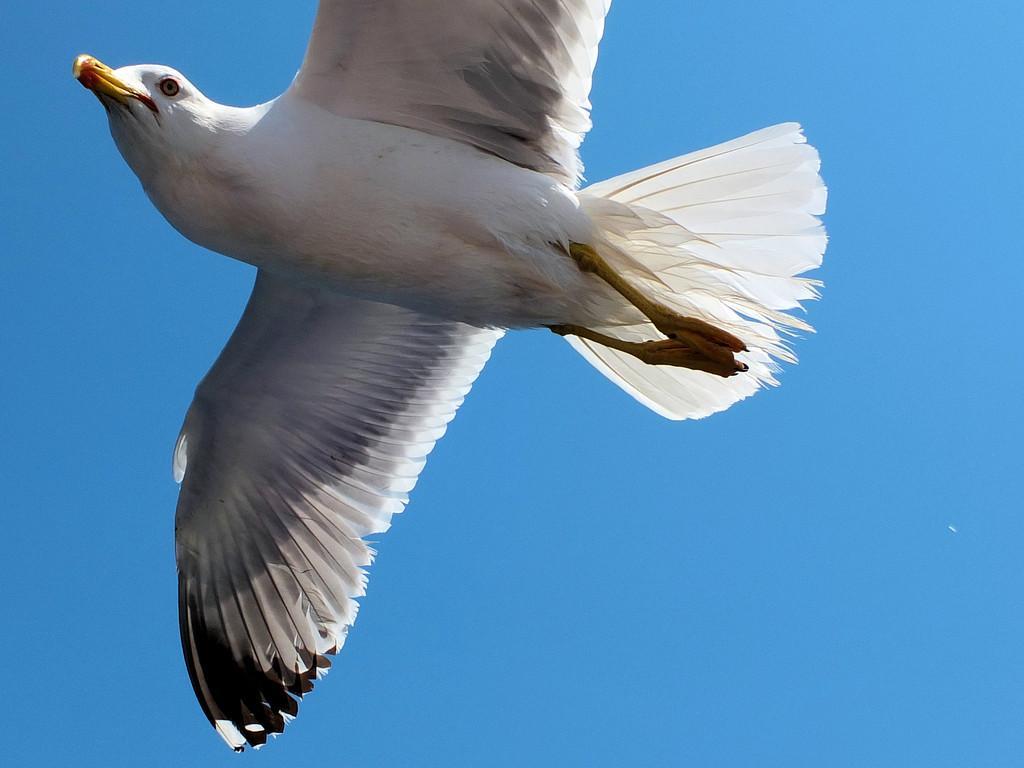How would you summarize this image in a sentence or two? In this image I can see a bird which is white, grey, yellow, orange and black in color is flying in the air. In the background I can see the sky. 